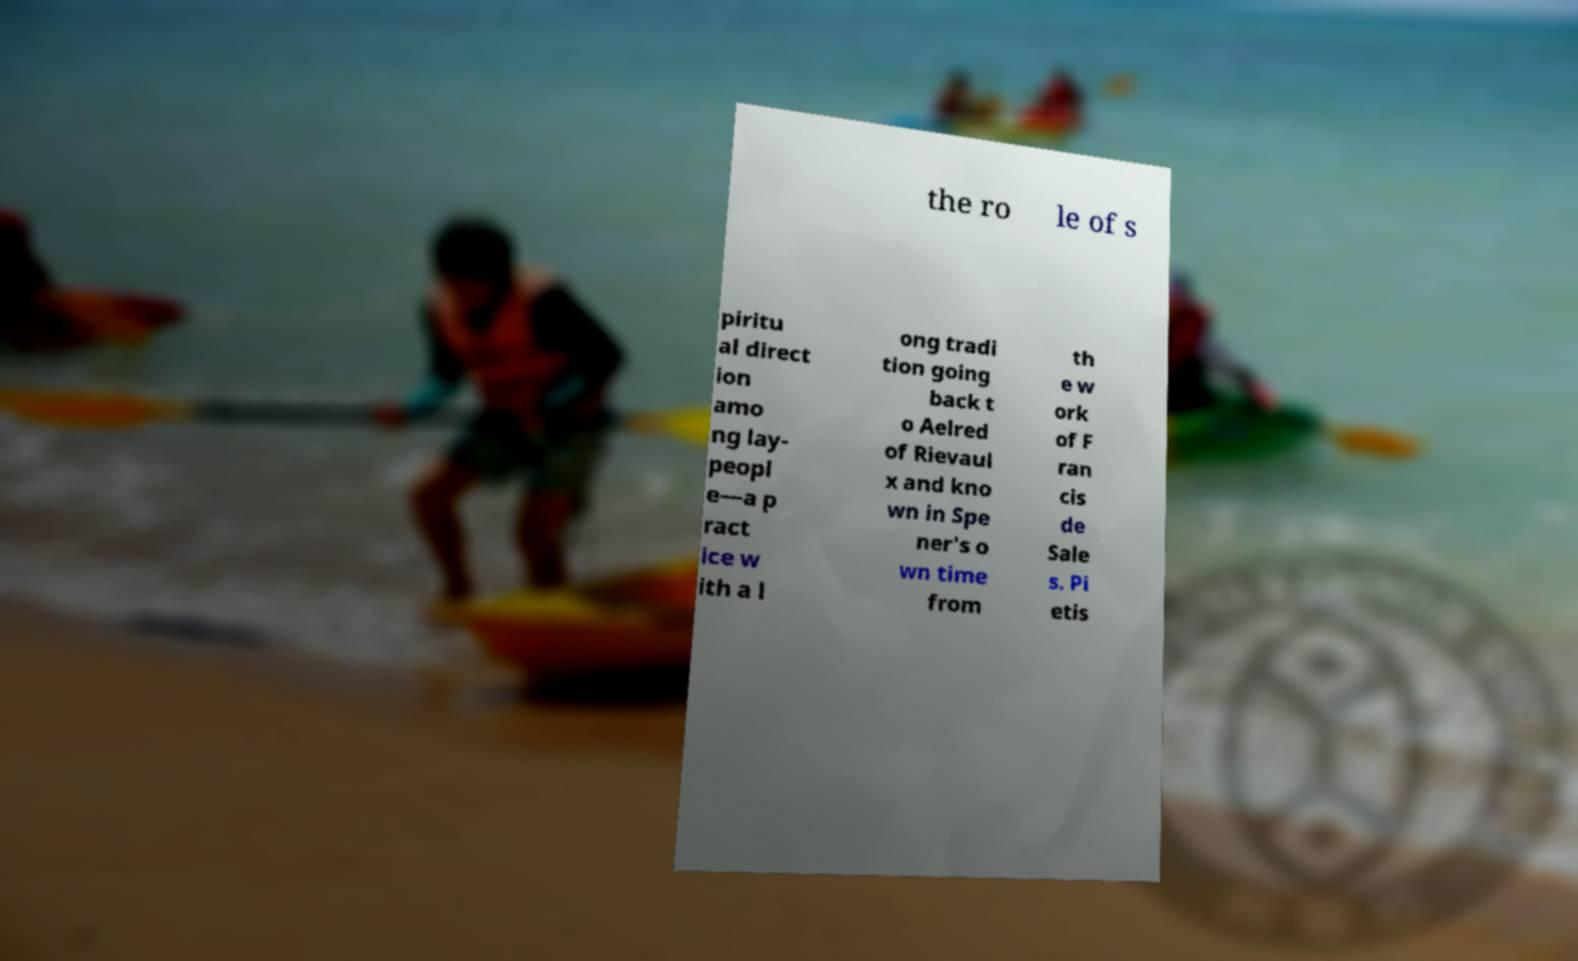For documentation purposes, I need the text within this image transcribed. Could you provide that? the ro le of s piritu al direct ion amo ng lay- peopl e—a p ract ice w ith a l ong tradi tion going back t o Aelred of Rievaul x and kno wn in Spe ner's o wn time from th e w ork of F ran cis de Sale s. Pi etis 